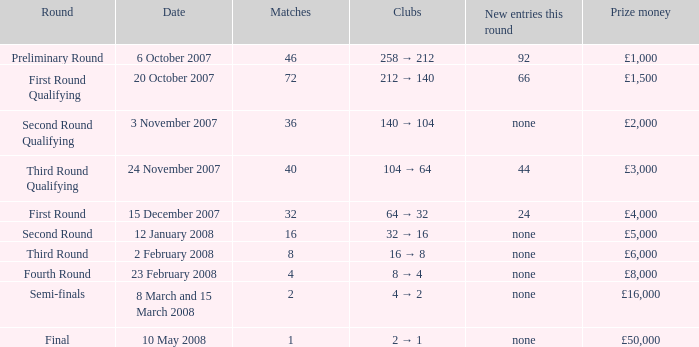How many new entries this round are there with more than 16 matches and a third round qualifying? 44.0. 